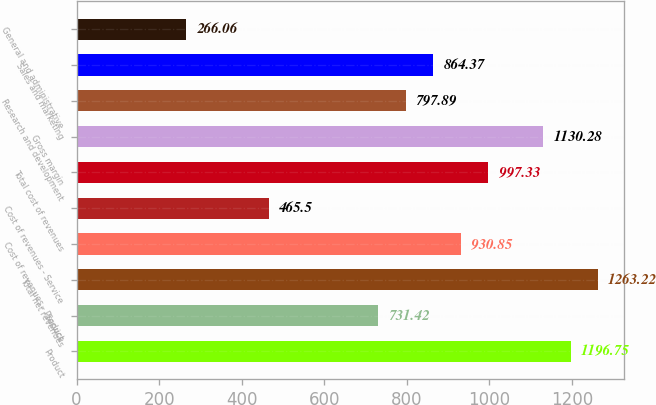Convert chart. <chart><loc_0><loc_0><loc_500><loc_500><bar_chart><fcel>Product<fcel>Service<fcel>Total net revenues<fcel>Cost of revenues - Product<fcel>Cost of revenues - Service<fcel>Total cost of revenues<fcel>Gross margin<fcel>Research and development<fcel>Sales and marketing<fcel>General and administrative<nl><fcel>1196.75<fcel>731.42<fcel>1263.22<fcel>930.85<fcel>465.5<fcel>997.33<fcel>1130.28<fcel>797.89<fcel>864.37<fcel>266.06<nl></chart> 